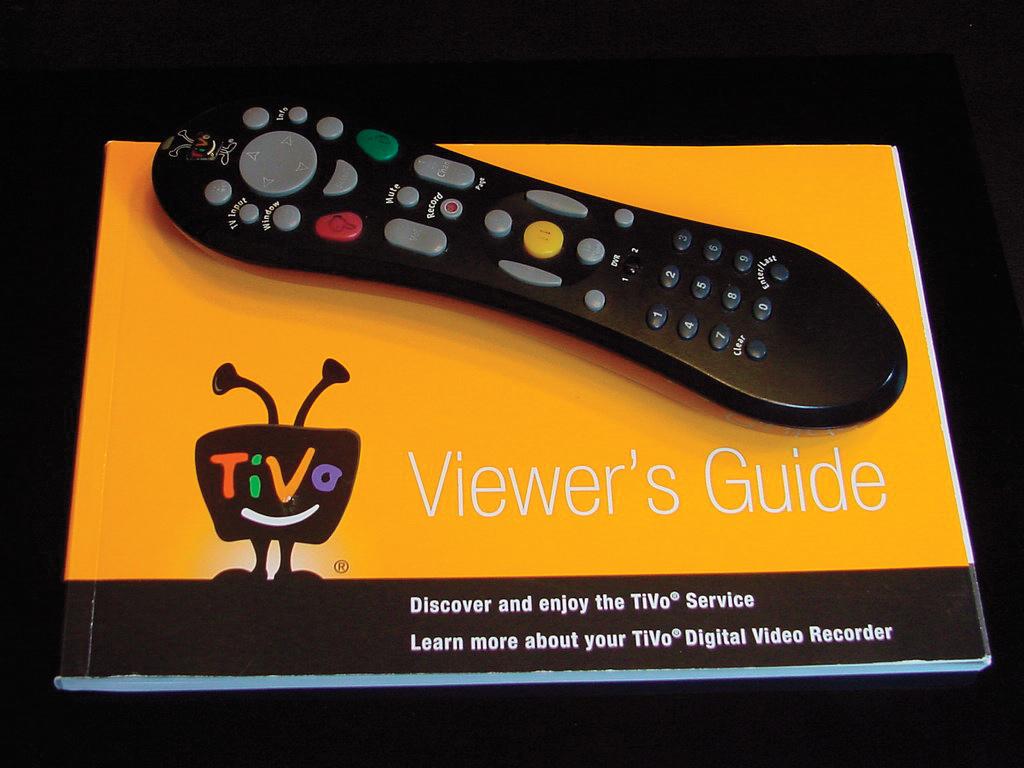What kind of a guide is it?
Your answer should be very brief. Viewer's. What does the bottom, left button do on this remote control?
Provide a succinct answer. Clear. 